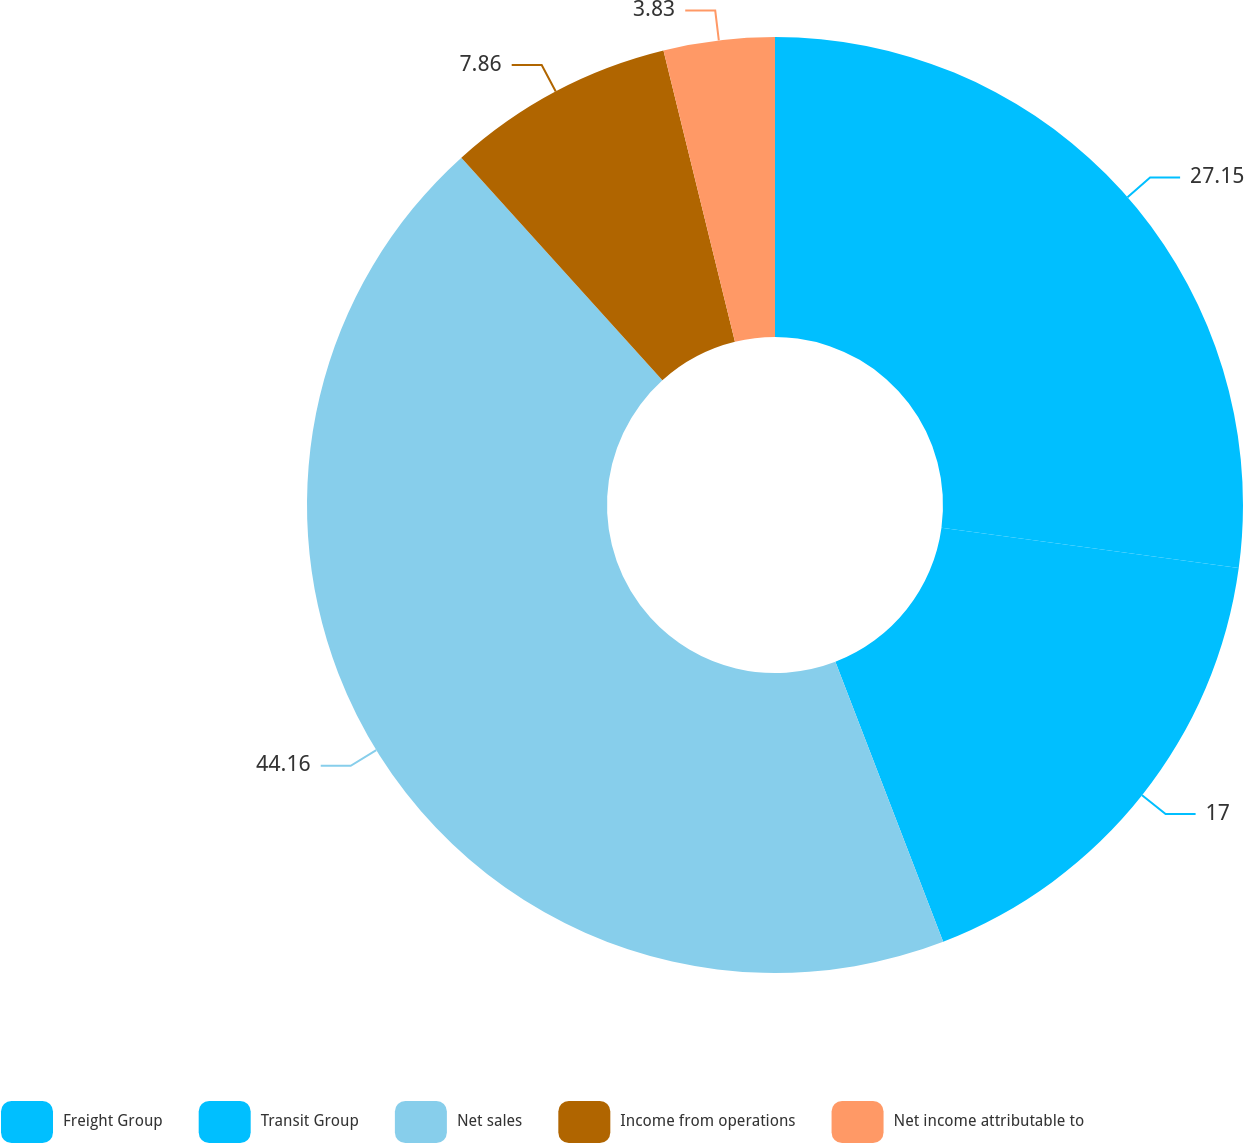Convert chart to OTSL. <chart><loc_0><loc_0><loc_500><loc_500><pie_chart><fcel>Freight Group<fcel>Transit Group<fcel>Net sales<fcel>Income from operations<fcel>Net income attributable to<nl><fcel>27.15%<fcel>17.0%<fcel>44.16%<fcel>7.86%<fcel>3.83%<nl></chart> 